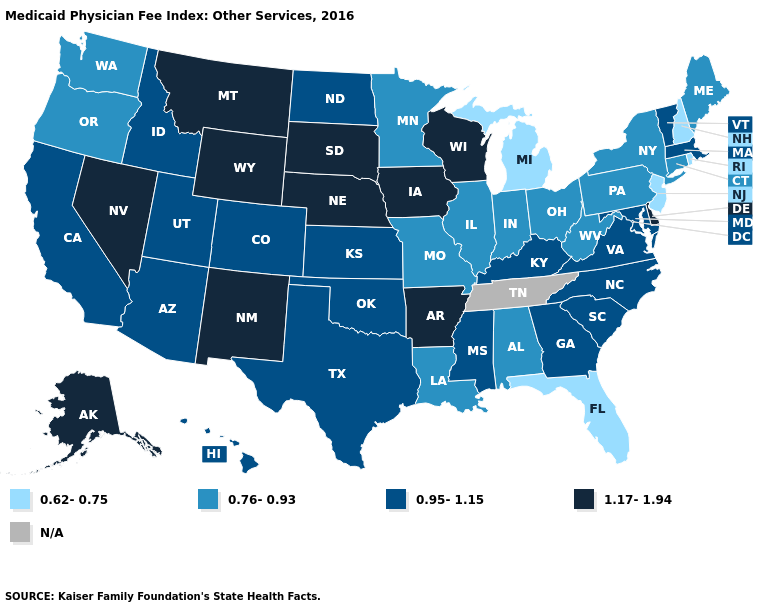Name the states that have a value in the range N/A?
Be succinct. Tennessee. How many symbols are there in the legend?
Answer briefly. 5. Name the states that have a value in the range N/A?
Keep it brief. Tennessee. Name the states that have a value in the range N/A?
Give a very brief answer. Tennessee. What is the lowest value in the Northeast?
Give a very brief answer. 0.62-0.75. Name the states that have a value in the range N/A?
Write a very short answer. Tennessee. Does the first symbol in the legend represent the smallest category?
Write a very short answer. Yes. Does Michigan have the highest value in the USA?
Write a very short answer. No. Is the legend a continuous bar?
Short answer required. No. What is the highest value in states that border Massachusetts?
Quick response, please. 0.95-1.15. Does New Hampshire have the highest value in the Northeast?
Give a very brief answer. No. What is the value of Washington?
Answer briefly. 0.76-0.93. Which states hav the highest value in the MidWest?
Give a very brief answer. Iowa, Nebraska, South Dakota, Wisconsin. Which states have the lowest value in the West?
Short answer required. Oregon, Washington. What is the value of Kansas?
Keep it brief. 0.95-1.15. 